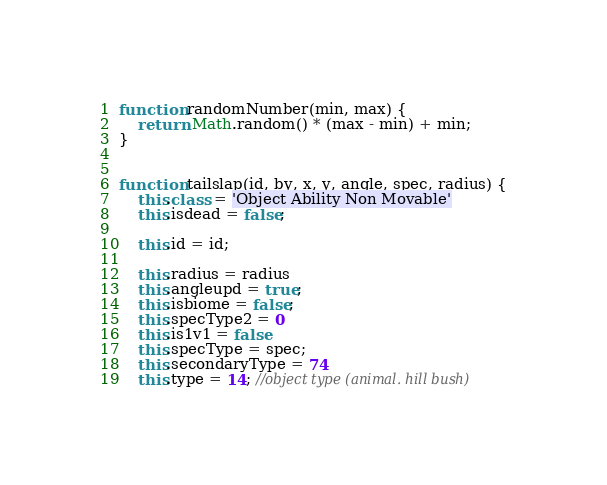<code> <loc_0><loc_0><loc_500><loc_500><_JavaScript_>
function randomNumber(min, max) {
    return Math.random() * (max - min) + min;
}


function tailslap(id, by, x, y, angle, spec, radius) {
    this.class = 'Object Ability Non Movable'
    this.isdead = false;

    this.id = id;

    this.radius = radius
    this.angleupd = true;
    this.isbiome = false;
    this.specType2 = 0
    this.is1v1 = false
    this.specType = spec;
    this.secondaryType = 74
    this.type = 14; //object type (animal. hill bush)</code> 